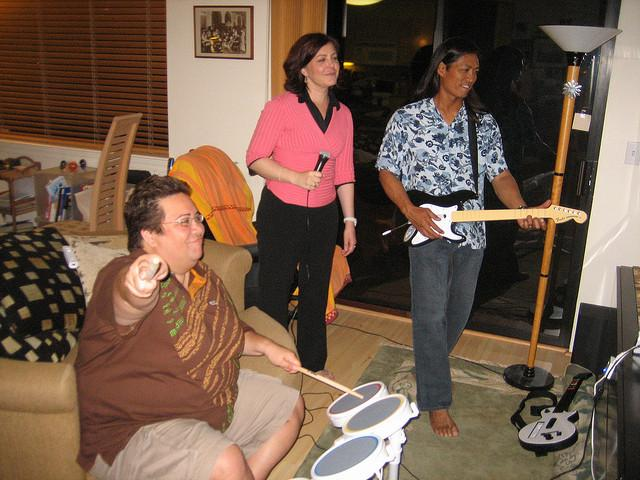What activity is being shared by the people? music 